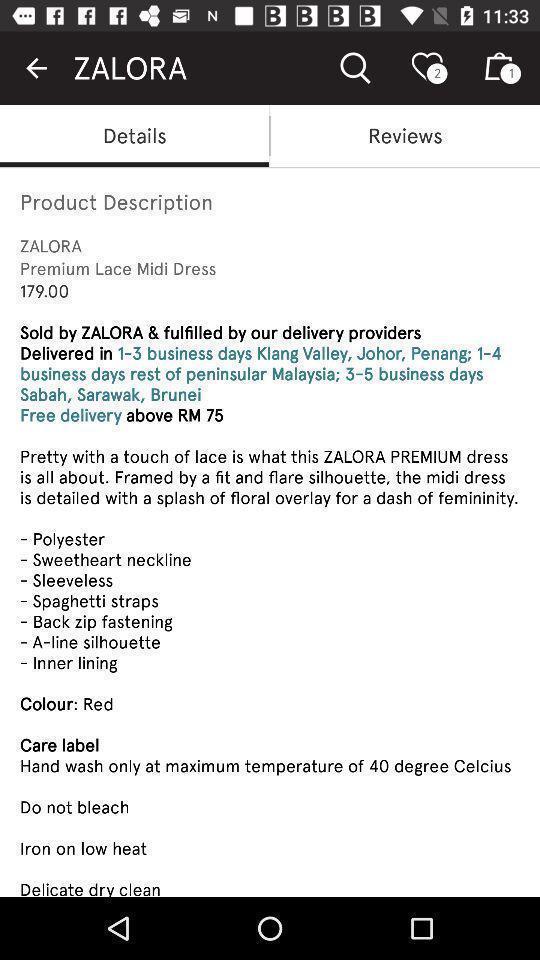Please provide a description for this image. Screen page displaying details of an item in shopping application. 